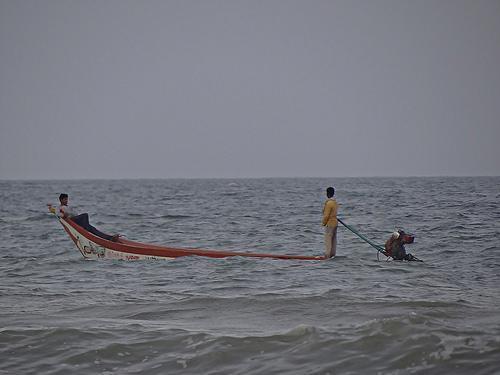How many boats are there?
Give a very brief answer. 1. How many people are shown?
Give a very brief answer. 2. 